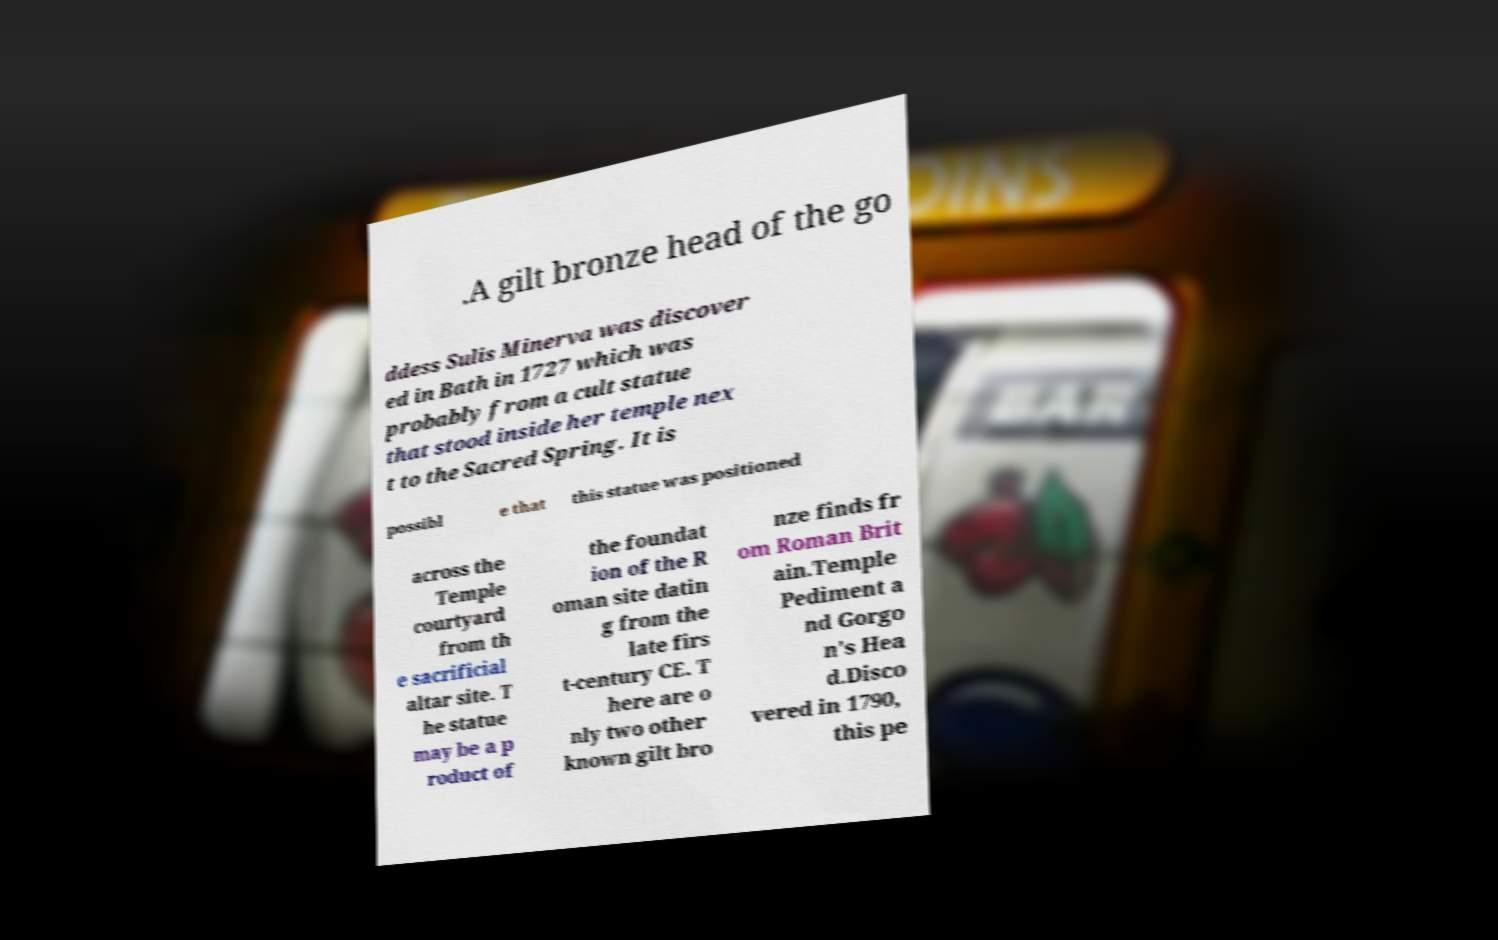Please identify and transcribe the text found in this image. .A gilt bronze head of the go ddess Sulis Minerva was discover ed in Bath in 1727 which was probably from a cult statue that stood inside her temple nex t to the Sacred Spring. It is possibl e that this statue was positioned across the Temple courtyard from th e sacrificial altar site. T he statue may be a p roduct of the foundat ion of the R oman site datin g from the late firs t-century CE. T here are o nly two other known gilt bro nze finds fr om Roman Brit ain.Temple Pediment a nd Gorgo n's Hea d.Disco vered in 1790, this pe 